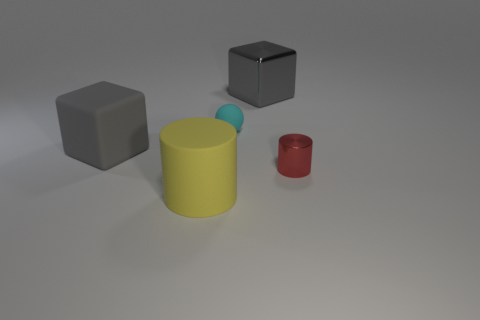There is a gray shiny object; is it the same shape as the large gray object on the left side of the big gray metal thing?
Keep it short and to the point. Yes. Are there the same number of large yellow things that are right of the small red cylinder and cyan things in front of the ball?
Your response must be concise. Yes. What shape is the rubber thing that is the same color as the large metal object?
Your response must be concise. Cube. There is a object that is on the left side of the yellow rubber cylinder; does it have the same color as the tiny object that is to the left of the tiny cylinder?
Keep it short and to the point. No. Is the number of small cyan rubber spheres in front of the red object greater than the number of green metallic things?
Give a very brief answer. No. What is the material of the yellow cylinder?
Provide a short and direct response. Rubber. What is the shape of the large yellow thing that is the same material as the cyan thing?
Offer a terse response. Cylinder. What size is the gray object on the right side of the cylinder in front of the red cylinder?
Provide a succinct answer. Large. What color is the big cube right of the rubber cylinder?
Offer a terse response. Gray. Are there any small yellow shiny objects of the same shape as the cyan object?
Keep it short and to the point. No. 